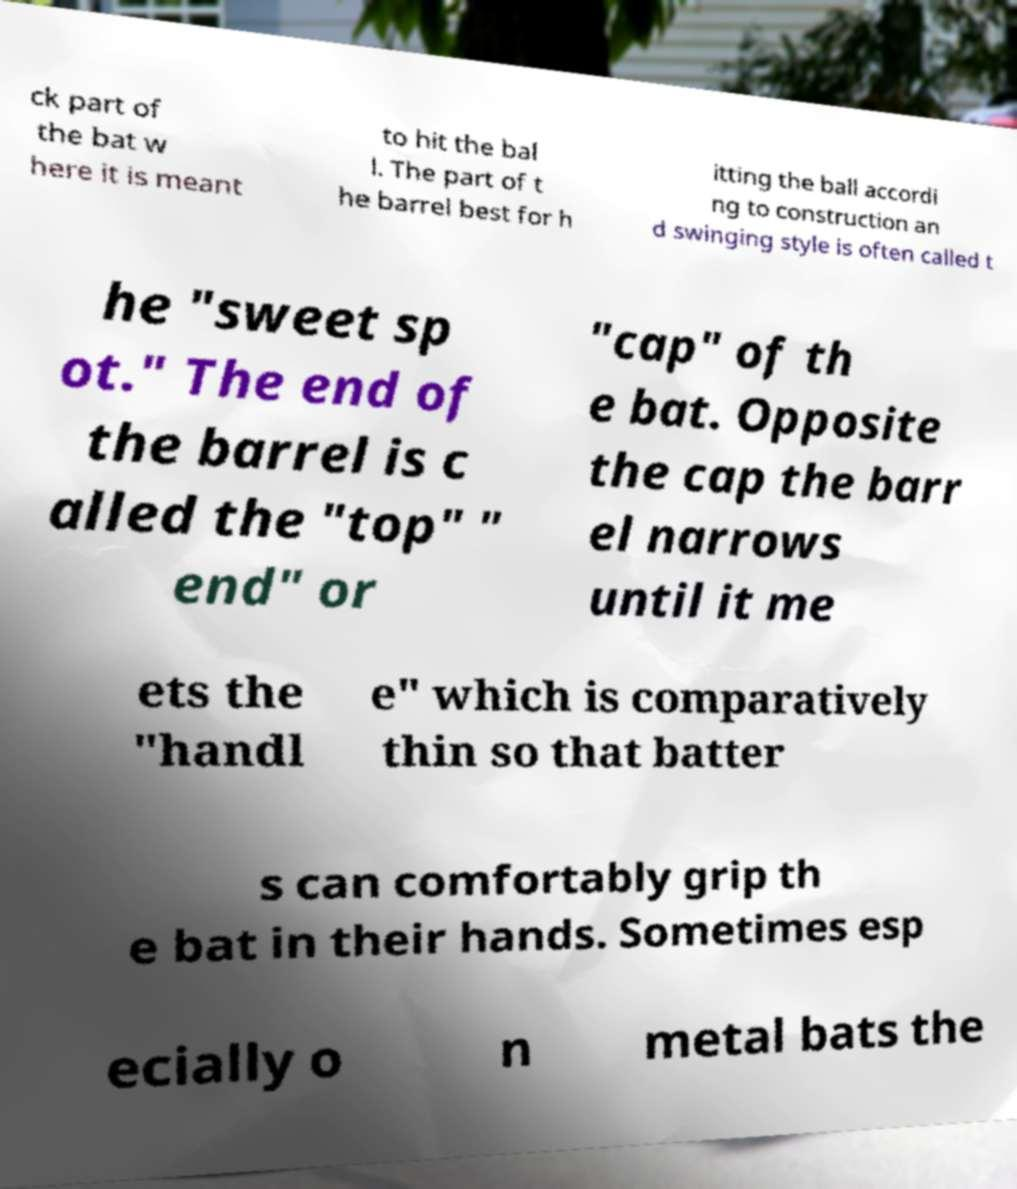Please identify and transcribe the text found in this image. ck part of the bat w here it is meant to hit the bal l. The part of t he barrel best for h itting the ball accordi ng to construction an d swinging style is often called t he "sweet sp ot." The end of the barrel is c alled the "top" " end" or "cap" of th e bat. Opposite the cap the barr el narrows until it me ets the "handl e" which is comparatively thin so that batter s can comfortably grip th e bat in their hands. Sometimes esp ecially o n metal bats the 